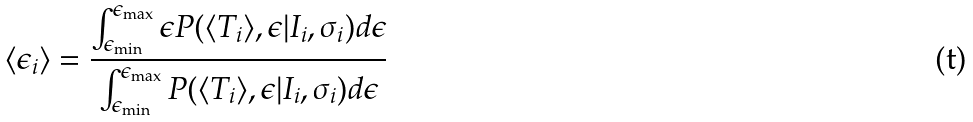<formula> <loc_0><loc_0><loc_500><loc_500>\langle \epsilon _ { i } \rangle = \frac { \int _ { \epsilon _ { \min } } ^ { \epsilon _ { \max } } \epsilon P ( \langle T _ { i } \rangle , \epsilon | I _ { i } , \sigma _ { i } ) d \epsilon } { \int _ { \epsilon _ { \min } } ^ { \epsilon _ { \max } } P ( \langle T _ { i } \rangle , \epsilon | I _ { i } , \sigma _ { i } ) d \epsilon }</formula> 